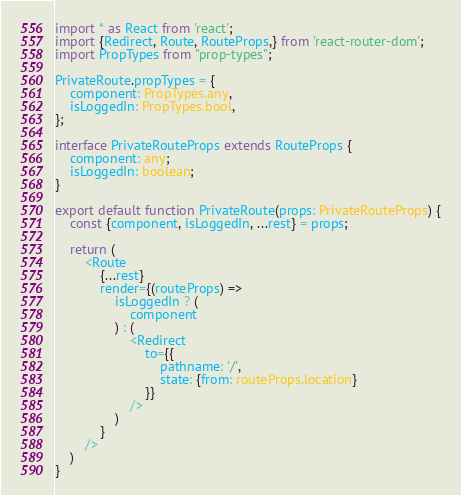Convert code to text. <code><loc_0><loc_0><loc_500><loc_500><_TypeScript_>import * as React from 'react';
import {Redirect, Route, RouteProps,} from 'react-router-dom';
import PropTypes from "prop-types";

PrivateRoute.propTypes = {
    component: PropTypes.any,
    isLoggedIn: PropTypes.bool,
};

interface PrivateRouteProps extends RouteProps {
    component: any;
    isLoggedIn: boolean;
}

export default function PrivateRoute(props: PrivateRouteProps) {
    const {component, isLoggedIn, ...rest} = props;

    return (
        <Route
            {...rest}
            render={(routeProps) =>
                isLoggedIn ? (
                    component
                ) : (
                    <Redirect
                        to={{
                            pathname: '/',
                            state: {from: routeProps.location}
                        }}
                    />
                )
            }
        />
    )
}</code> 